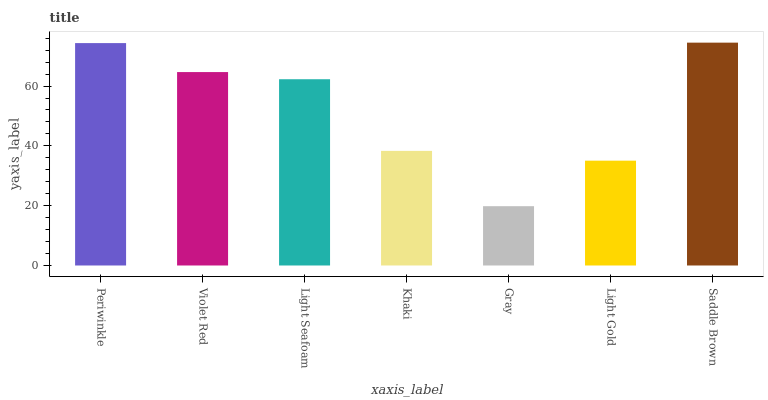Is Gray the minimum?
Answer yes or no. Yes. Is Saddle Brown the maximum?
Answer yes or no. Yes. Is Violet Red the minimum?
Answer yes or no. No. Is Violet Red the maximum?
Answer yes or no. No. Is Periwinkle greater than Violet Red?
Answer yes or no. Yes. Is Violet Red less than Periwinkle?
Answer yes or no. Yes. Is Violet Red greater than Periwinkle?
Answer yes or no. No. Is Periwinkle less than Violet Red?
Answer yes or no. No. Is Light Seafoam the high median?
Answer yes or no. Yes. Is Light Seafoam the low median?
Answer yes or no. Yes. Is Light Gold the high median?
Answer yes or no. No. Is Violet Red the low median?
Answer yes or no. No. 